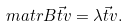Convert formula to latex. <formula><loc_0><loc_0><loc_500><loc_500>& \ m a t r { B } \vec { t } { v } = \lambda \vec { t } { v } .</formula> 